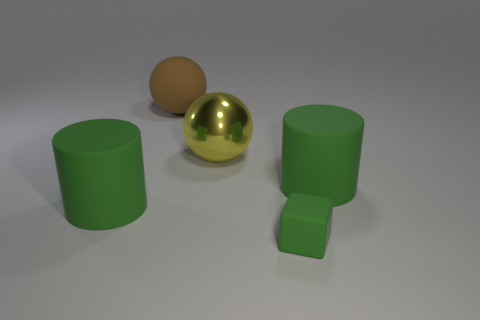Add 3 blocks. How many objects exist? 8 Subtract all spheres. How many objects are left? 3 Subtract all small things. Subtract all cubes. How many objects are left? 3 Add 5 large brown rubber spheres. How many large brown rubber spheres are left? 6 Add 1 yellow balls. How many yellow balls exist? 2 Subtract 1 green blocks. How many objects are left? 4 